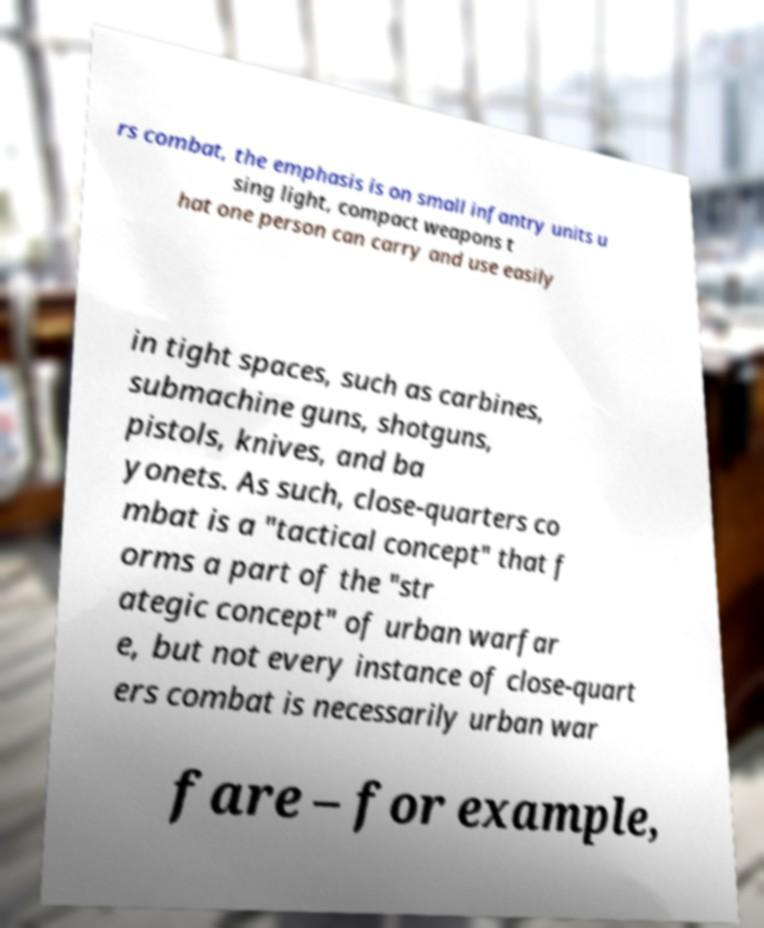Can you read and provide the text displayed in the image?This photo seems to have some interesting text. Can you extract and type it out for me? rs combat, the emphasis is on small infantry units u sing light, compact weapons t hat one person can carry and use easily in tight spaces, such as carbines, submachine guns, shotguns, pistols, knives, and ba yonets. As such, close-quarters co mbat is a "tactical concept" that f orms a part of the "str ategic concept" of urban warfar e, but not every instance of close-quart ers combat is necessarily urban war fare – for example, 